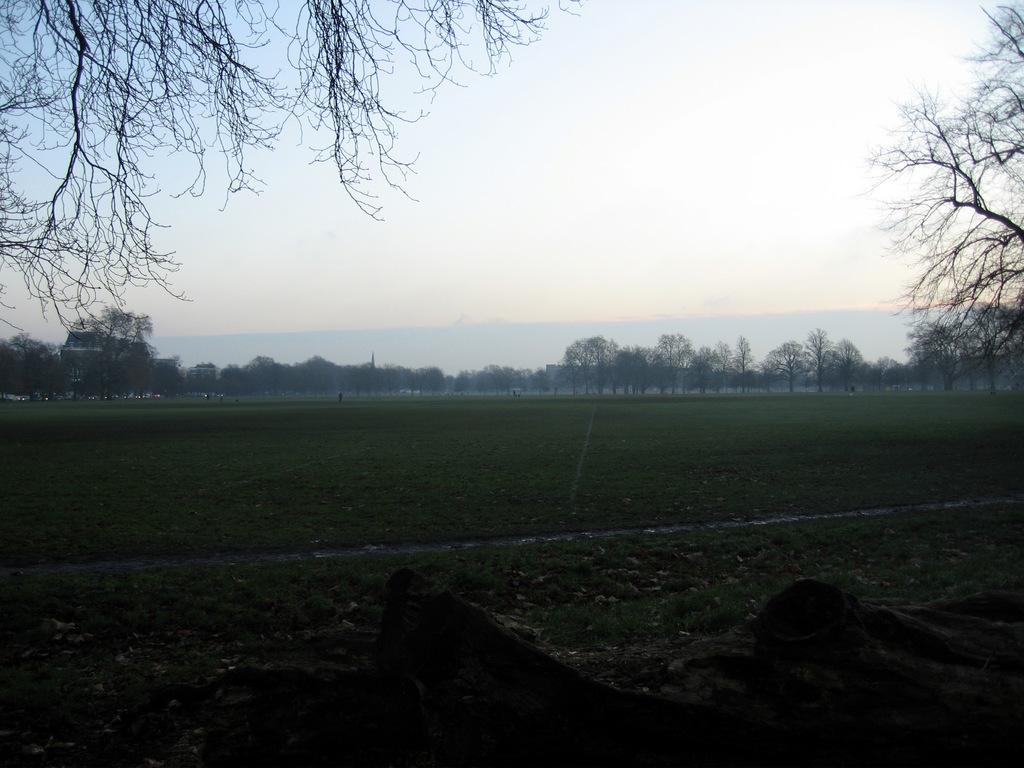What type of vegetation is present in the image? There are trees in the image. What type of ground cover is present in the image? There is grass in the image. What type of structure is present in the image? There is a building in the image. What other objects can be seen on the ground in the image? There are other objects on the ground in the image. What can be seen in the background of the image? The sky is visible in the background of the image. What type of shop can be seen in the image? There is no shop present in the image. How does the ice affect the trees in the image? There is no ice present in the image, so it cannot affect the trees. 